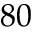<formula> <loc_0><loc_0><loc_500><loc_500>8 0</formula> 